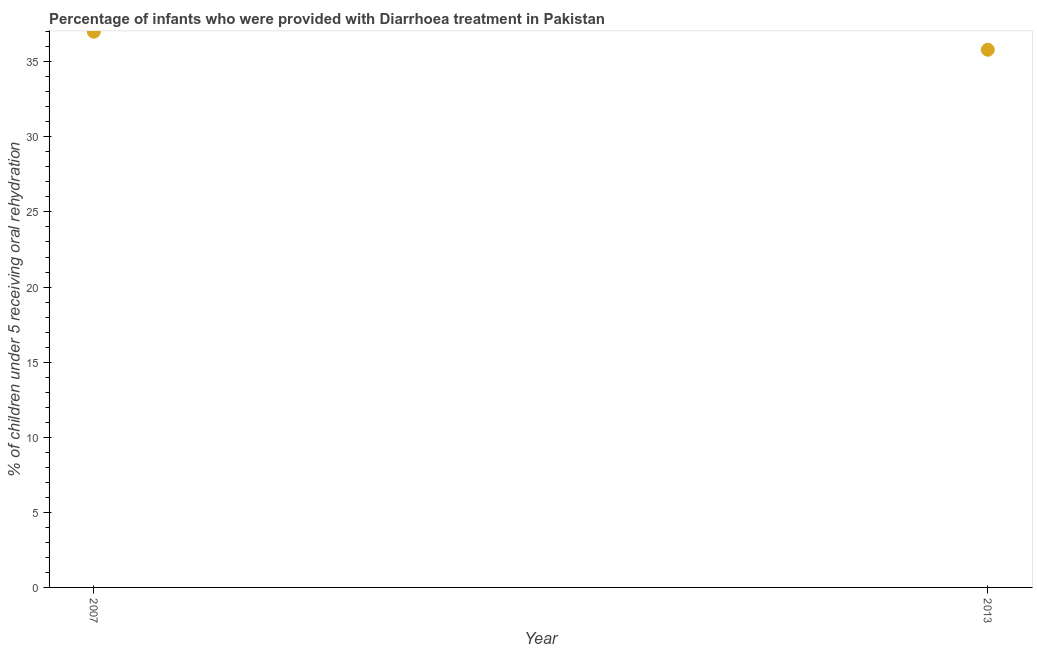Across all years, what is the minimum percentage of children who were provided with treatment diarrhoea?
Ensure brevity in your answer.  35.8. In which year was the percentage of children who were provided with treatment diarrhoea maximum?
Make the answer very short. 2007. In which year was the percentage of children who were provided with treatment diarrhoea minimum?
Offer a terse response. 2013. What is the sum of the percentage of children who were provided with treatment diarrhoea?
Your response must be concise. 72.8. What is the difference between the percentage of children who were provided with treatment diarrhoea in 2007 and 2013?
Offer a terse response. 1.2. What is the average percentage of children who were provided with treatment diarrhoea per year?
Offer a terse response. 36.4. What is the median percentage of children who were provided with treatment diarrhoea?
Make the answer very short. 36.4. What is the ratio of the percentage of children who were provided with treatment diarrhoea in 2007 to that in 2013?
Your response must be concise. 1.03. Is the percentage of children who were provided with treatment diarrhoea in 2007 less than that in 2013?
Ensure brevity in your answer.  No. In how many years, is the percentage of children who were provided with treatment diarrhoea greater than the average percentage of children who were provided with treatment diarrhoea taken over all years?
Your response must be concise. 1. Does the percentage of children who were provided with treatment diarrhoea monotonically increase over the years?
Provide a short and direct response. No. What is the difference between two consecutive major ticks on the Y-axis?
Offer a terse response. 5. What is the title of the graph?
Provide a succinct answer. Percentage of infants who were provided with Diarrhoea treatment in Pakistan. What is the label or title of the X-axis?
Your answer should be very brief. Year. What is the label or title of the Y-axis?
Offer a terse response. % of children under 5 receiving oral rehydration. What is the % of children under 5 receiving oral rehydration in 2007?
Give a very brief answer. 37. What is the % of children under 5 receiving oral rehydration in 2013?
Offer a very short reply. 35.8. What is the ratio of the % of children under 5 receiving oral rehydration in 2007 to that in 2013?
Your answer should be very brief. 1.03. 